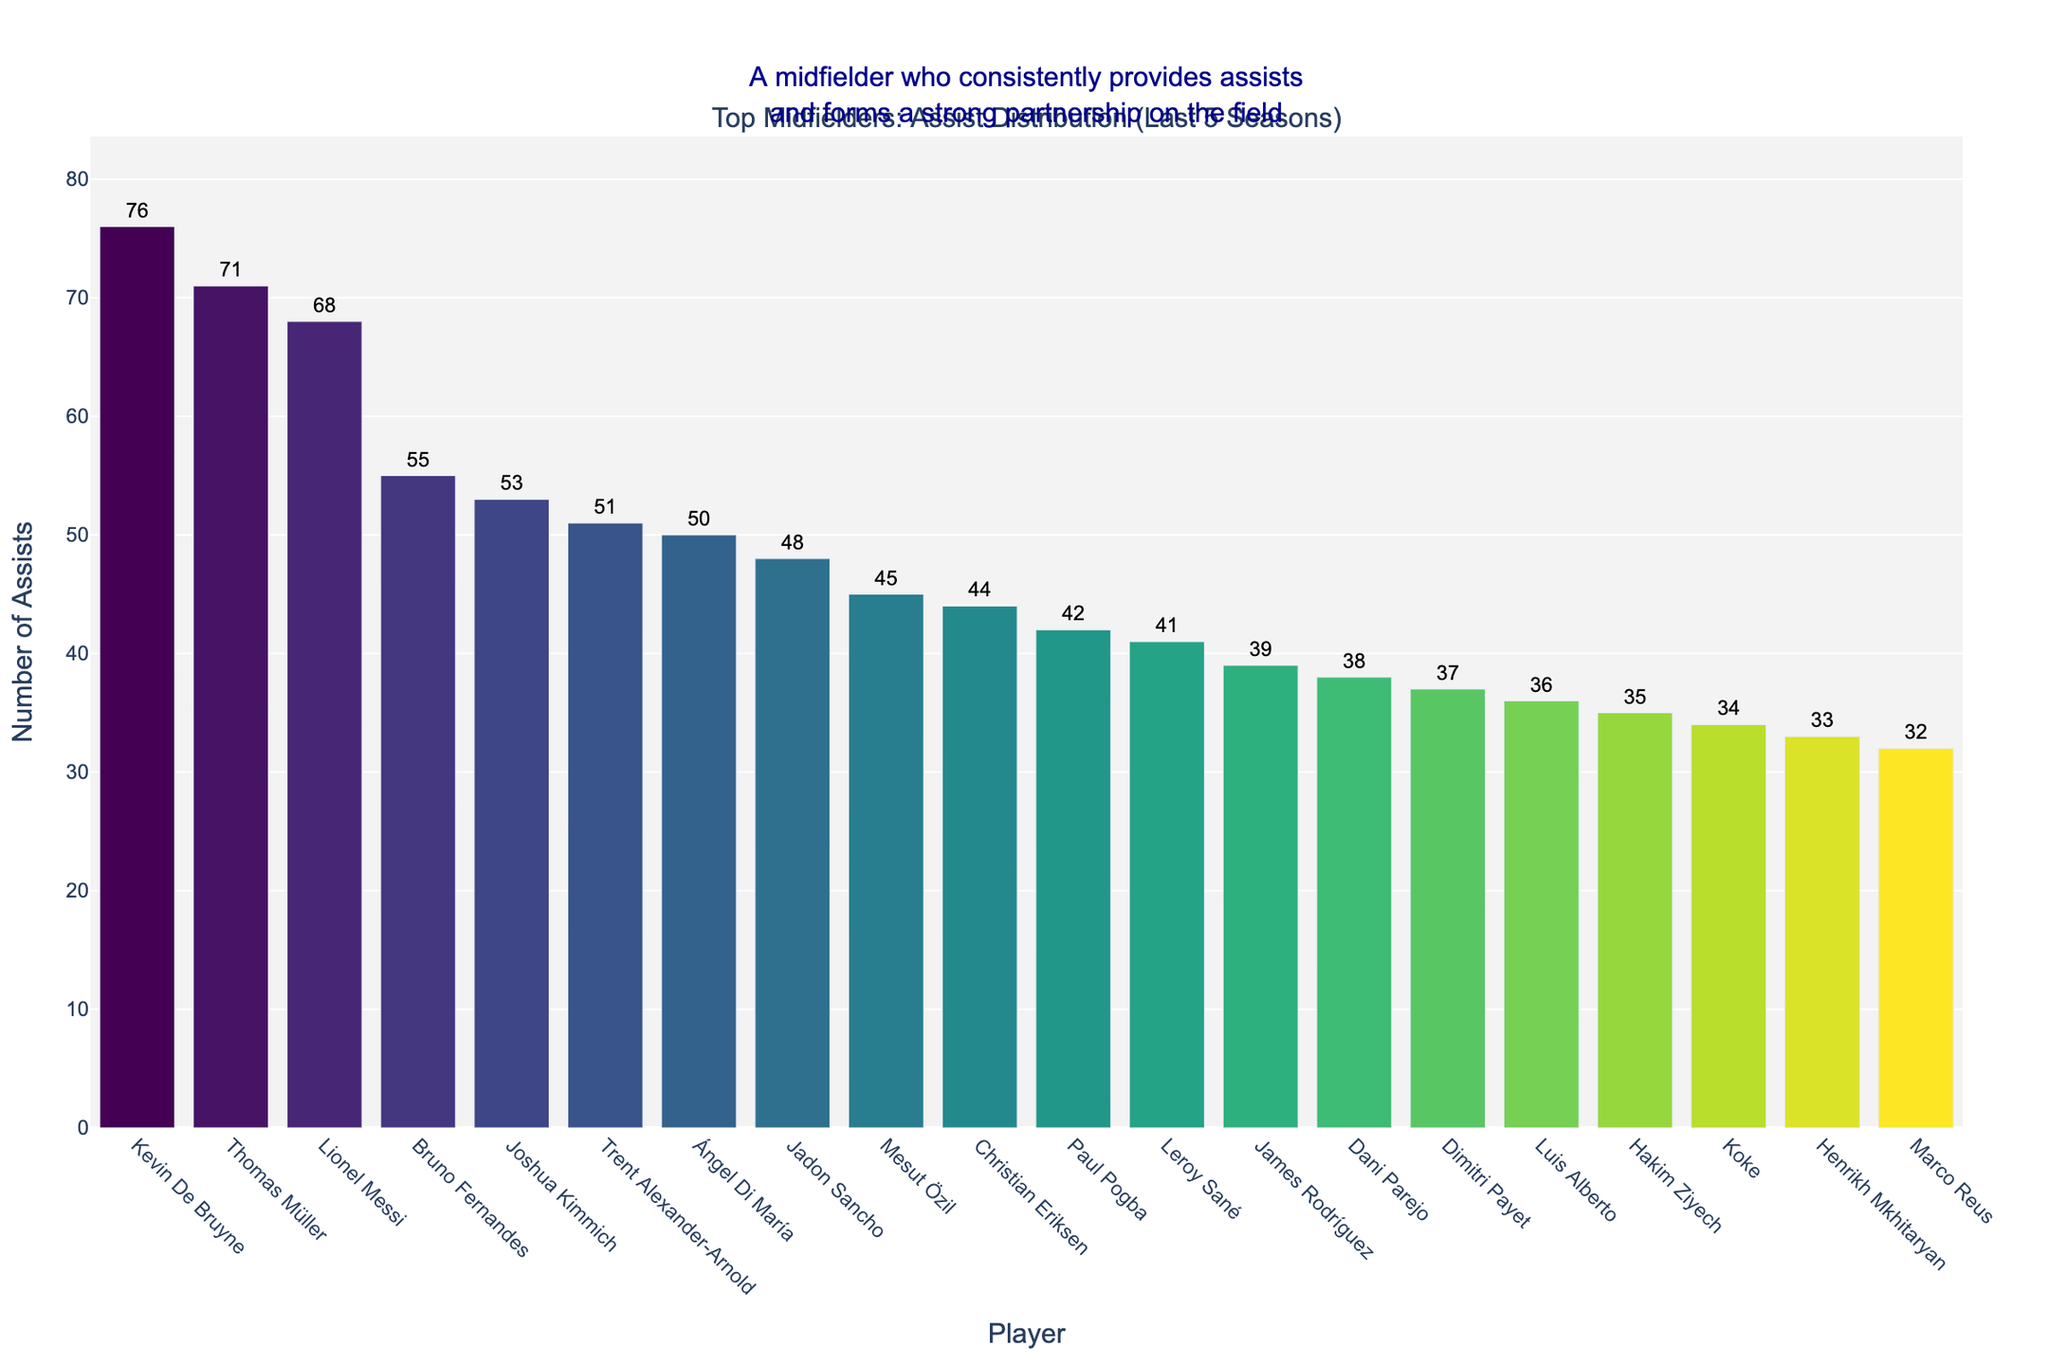What's the total number of assists made by the top 5 players? To find the total number of assists by the top 5 players, sum the assists of Kevin De Bruyne (76), Thomas Müller (71), Lionel Messi (68), Bruno Fernandes (55), and Joshua Kimmich (53). So, 76 + 71 + 68 + 55 + 53 = 323 assists.
Answer: 323 Who has provided the most assists, and how many did they provide? The bar for Kevin De Bruyne is the highest in the figure, indicating he provided the most assists, which is 76.
Answer: Kevin De Bruyne, 76 What is the difference in assists between the player with the highest assists and the player with the lowest assists? To find the difference, identify the player with the highest assists (Kevin De Bruyne with 76) and the player with the lowest assists (Marco Reus with 32). The difference is 76 - 32 = 44.
Answer: 44 Which player is positioned fifth in the number of assists? The fifth bar from the left represents Joshua Kimmich, indicating he has the fifth highest number of assists.
Answer: Joshua Kimmich On average, how many assists have the top 10 players provided? Sum the assists of the top 10 players and then divide by 10. The sum is 76 (Kevin De Bruyne) + 71 (Thomas Müller) + 68 (Lionel Messi) + 55 (Bruno Fernandes) + 53 (Joshua Kimmich) + 51 (Trent Alexander-Arnold) + 50 (Ángel Di María) + 48 (Jadon Sancho) + 45 (Mesut Özil) + 44 (Christian Eriksen) = 561. So, 561 / 10 = 56.1
Answer: 56.1 Which players have provided between 35 and 50 assists? Identifying bars with assists between 35 and 50, they are Ángel Di María (50), Jadon Sancho (48), Mesut Özil (45), Christian Eriksen (44), Paul Pogba (42), Leroy Sané (41), and James Rodríguez (39), Dani Parejo (38), and Dimitri Payet (37).
Answer: Ángel Di María, Jadon Sancho, Mesut Özil, Christian Eriksen, Paul Pogba, Leroy Sané, James Rodríguez, Dani Parejo, Dimitri Payet How many players have provided more than 50 assists? Count the bars in the plot with a height greater than 50 assists. Kevin De Bruyne (76), Thomas Müller (71), Lionel Messi (68), Bruno Fernandes (55), and Joshua Kimmich (53) have provided more than 50 assists. There are 5 players.
Answer: 5 What is the range of assists among the top 20 players? The range is the difference between the highest and lowest number of assists in the dataset. This is Kevin De Bruyne with 76 assists and Marco Reus with 32 assists. So, 76 - 32 = 44.
Answer: 44 